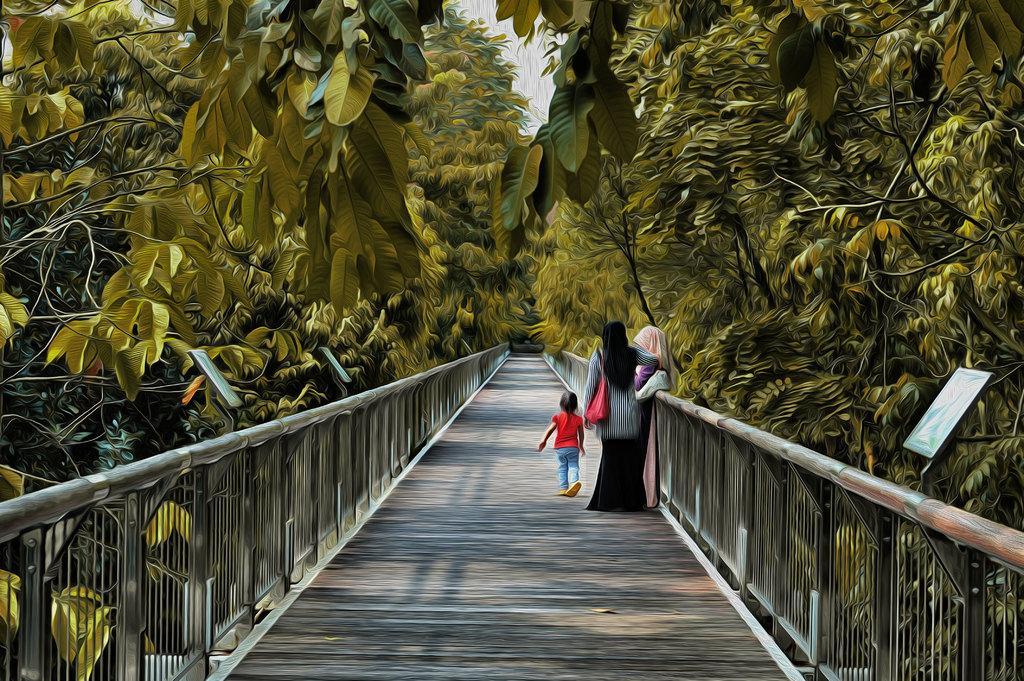Could you give a brief overview of what you see in this image? This picture contains two women are standing on the bridge and a girl in red dress is walking on the bridge. On either side of the bridge, there are street lights and trees. 